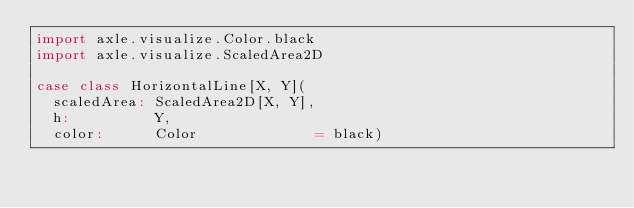<code> <loc_0><loc_0><loc_500><loc_500><_Scala_>import axle.visualize.Color.black
import axle.visualize.ScaledArea2D

case class HorizontalLine[X, Y](
  scaledArea: ScaledArea2D[X, Y],
  h:          Y,
  color:      Color              = black)
</code> 